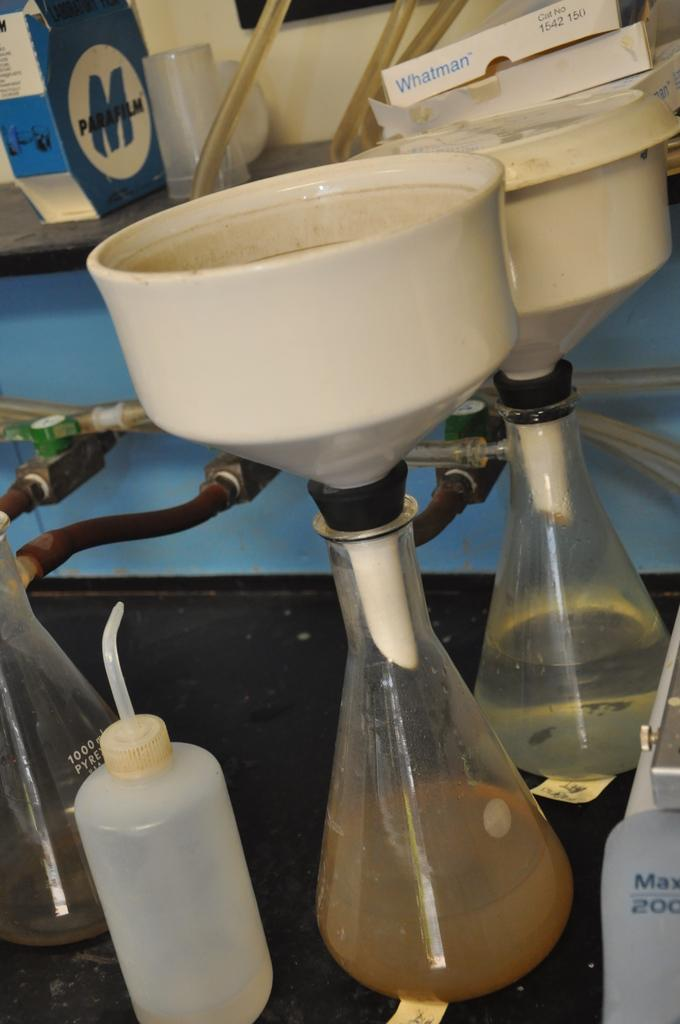What type of setting is shown in the image? The image depicts a laboratory. What can be found in a laboratory? Laboratory equipment is present in the image. What division of the company is responsible for the bag in the image? There is no bag present in the image, so it is not possible to determine which division of the company might be responsible. 